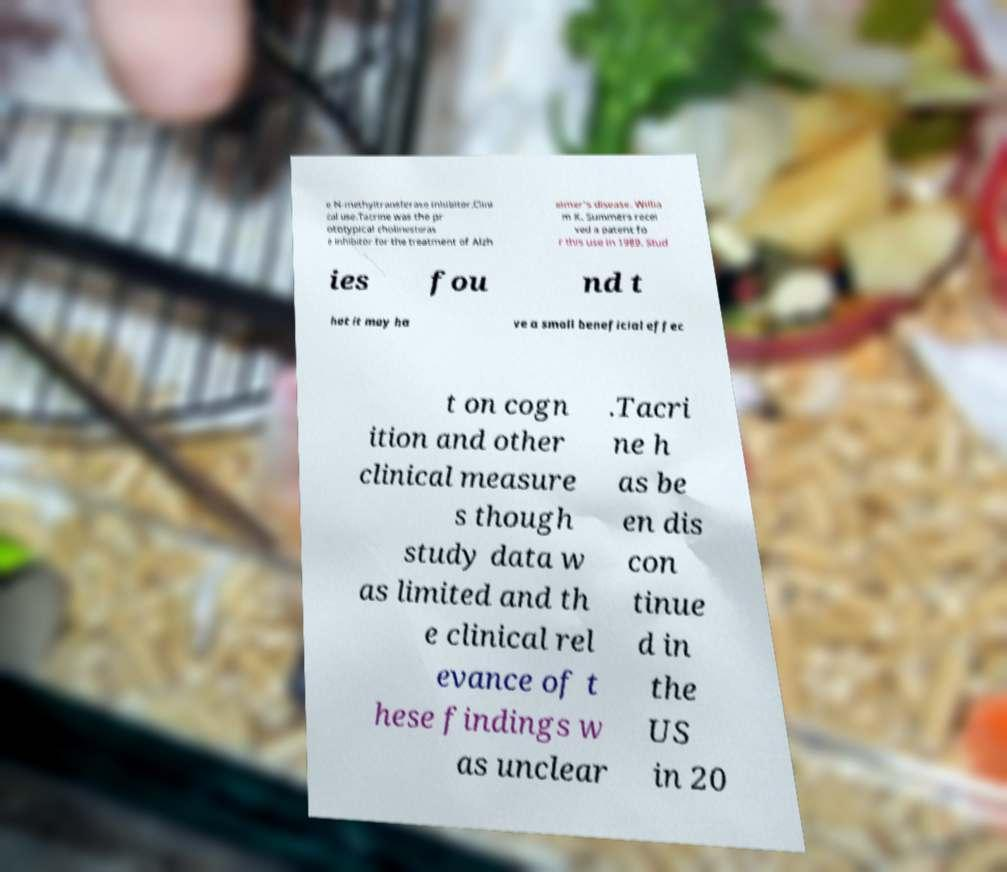There's text embedded in this image that I need extracted. Can you transcribe it verbatim? e N-methyltransferase inhibitor.Clini cal use.Tacrine was the pr ototypical cholinesteras e inhibitor for the treatment of Alzh eimer's disease. Willia m K. Summers recei ved a patent fo r this use in 1989. Stud ies fou nd t hat it may ha ve a small beneficial effec t on cogn ition and other clinical measure s though study data w as limited and th e clinical rel evance of t hese findings w as unclear .Tacri ne h as be en dis con tinue d in the US in 20 